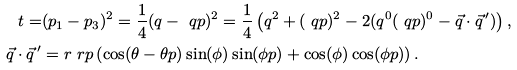Convert formula to latex. <formula><loc_0><loc_0><loc_500><loc_500>t = & ( p _ { 1 } - p _ { 3 } ) ^ { 2 } = \frac { 1 } { 4 } ( q - \ q p ) ^ { 2 } = \frac { 1 } { 4 } \left ( q ^ { 2 } + ( \ q p ) ^ { 2 } - 2 ( q ^ { 0 } ( \ q p ) ^ { 0 } - \vec { q } \cdot \vec { q } \, ^ { \prime } ) \right ) , \\ \vec { q } \cdot \vec { q } \, ^ { \prime } & = r \ r p \left ( \cos ( \theta - \theta p ) \sin ( \phi ) \sin ( \phi p ) + \cos ( \phi ) \cos ( \phi p ) \right ) .</formula> 